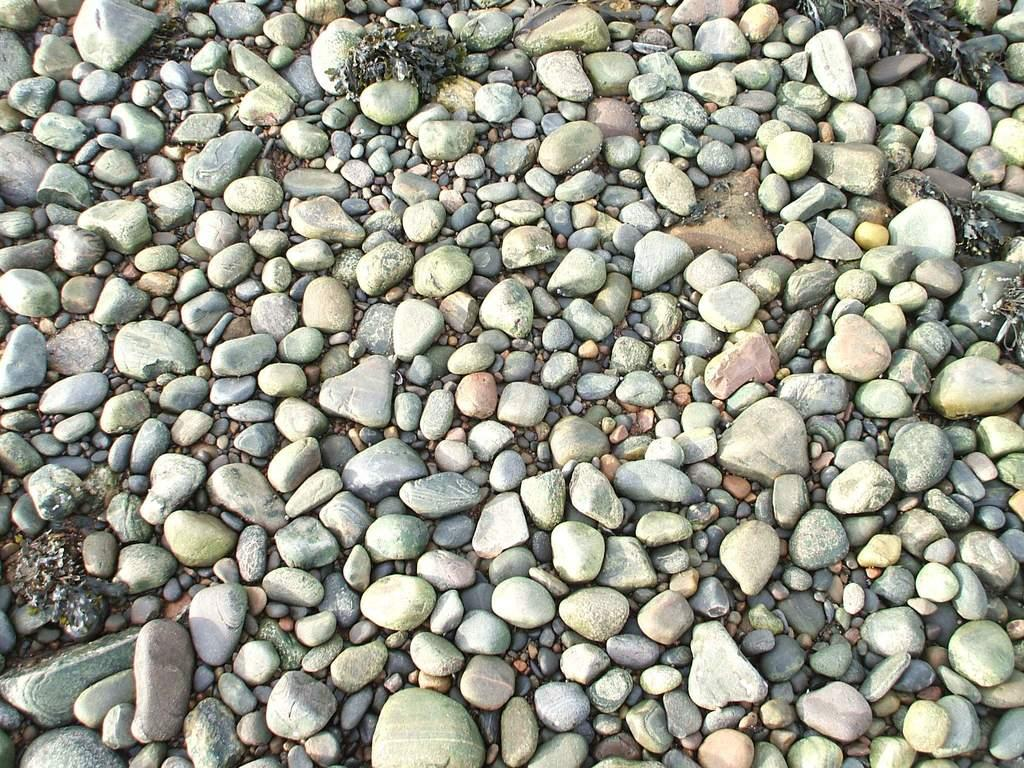What type of objects can be seen on the ground in the image? There are stones on the ground in the image. How many rings are visible on the stones in the image? There are no rings present on the stones in the image. What shape do the stones have in the image? The provided facts do not mention the shape of the stones, so we cannot definitively answer this question based on the information given. 